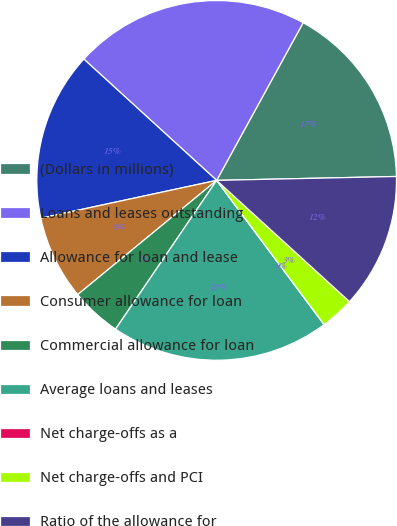<chart> <loc_0><loc_0><loc_500><loc_500><pie_chart><fcel>(Dollars in millions)<fcel>Loans and leases outstanding<fcel>Allowance for loan and lease<fcel>Consumer allowance for loan<fcel>Commercial allowance for loan<fcel>Average loans and leases<fcel>Net charge-offs as a<fcel>Net charge-offs and PCI<fcel>Ratio of the allowance for<nl><fcel>16.67%<fcel>21.21%<fcel>15.15%<fcel>7.58%<fcel>4.55%<fcel>19.7%<fcel>0.0%<fcel>3.03%<fcel>12.12%<nl></chart> 